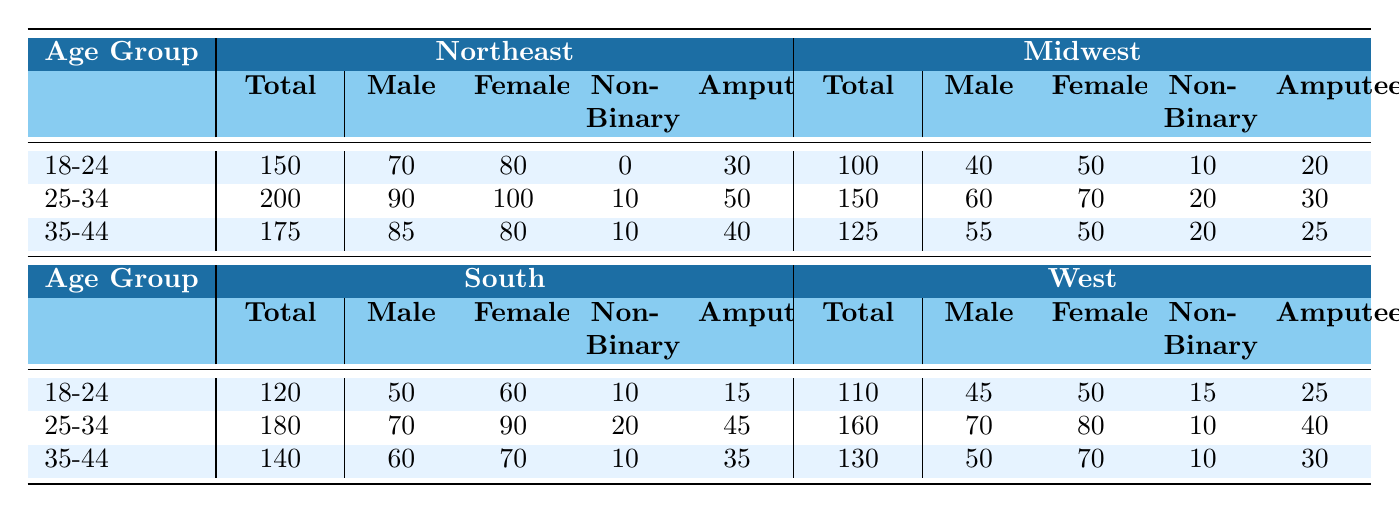What is the total number of participants in the age group 25-34 for the Northeast region? To find the total number of participants in the age group 25-34 for the Northeast region, we look at the 'Total' column for that age group in the Northeast section, which states 200 participants.
Answer: 200 How many male participants are there in the Midwest for the age group 18-24? The table shows that in the age group 18-24 for the Midwest region, the 'Male' column indicates there are 40 male participants.
Answer: 40 In which region do participants aged 35-44 have the highest number of amputees? We can compare the 'Amputee' values for age group 35-44 across all regions: Northeast (40), Midwest (25), South (35), and West (30). The highest value is 40 in the Northeast region.
Answer: Northeast What is the total number of female participants across all regions in the age group 25-34? For the age group 25-34, we will add the female participants across all regions: Northeast (100), Midwest (70), South (90), and West (80). The total calculation is 100 + 70 + 90 + 80 = 340.
Answer: 340 Is it true that the number of non-binary participants in the South region exceeds that of the Midwest region in the age group 18-24? In the age group 18-24, the South region has 10 non-binary participants, while the Midwest region has 10 as well. Since they are equal, the statement is false.
Answer: No What is the overall total number of amputee participants aged 18-24 across all regions? We will find the number of amputees in the age group 18-24 for each region: Northeast (30), Midwest (20), South (15), and West (25). The total is calculated as 30 + 20 + 15 + 25 = 90.
Answer: 90 Which age group has the highest number of total participants in the West region? We compare the total participants for each age group in the West region: 18-24 (110), 25-34 (160), and 35-44 (130). Thus, the highest is in the age group 25-34 with 160 participants.
Answer: 25-34 How many total participants are in the Northeast region combined for the age groups 35-44 and 25-34? To find the combined total for age groups 35-44 and 25-34 in the Northeast region, we sum the participant totals: 175 (35-44) + 200 (25-34) = 375.
Answer: 375 